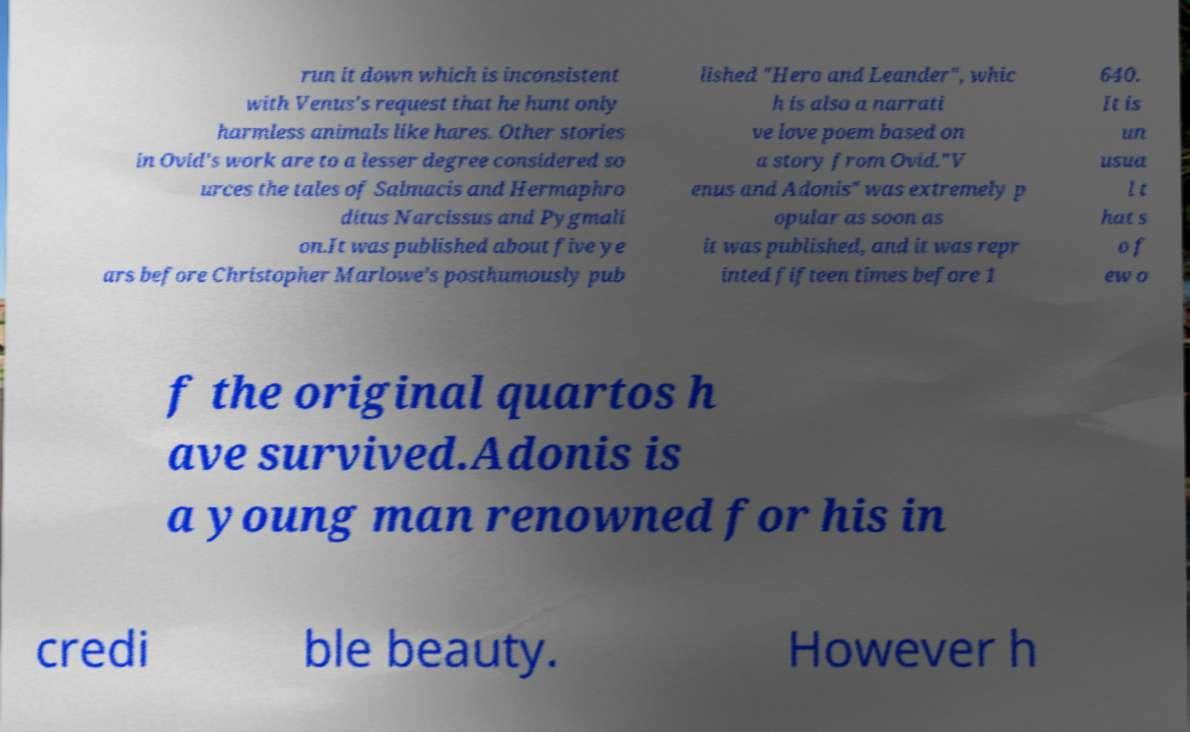Can you accurately transcribe the text from the provided image for me? run it down which is inconsistent with Venus's request that he hunt only harmless animals like hares. Other stories in Ovid's work are to a lesser degree considered so urces the tales of Salmacis and Hermaphro ditus Narcissus and Pygmali on.It was published about five ye ars before Christopher Marlowe's posthumously pub lished "Hero and Leander", whic h is also a narrati ve love poem based on a story from Ovid."V enus and Adonis" was extremely p opular as soon as it was published, and it was repr inted fifteen times before 1 640. It is un usua l t hat s o f ew o f the original quartos h ave survived.Adonis is a young man renowned for his in credi ble beauty. However h 